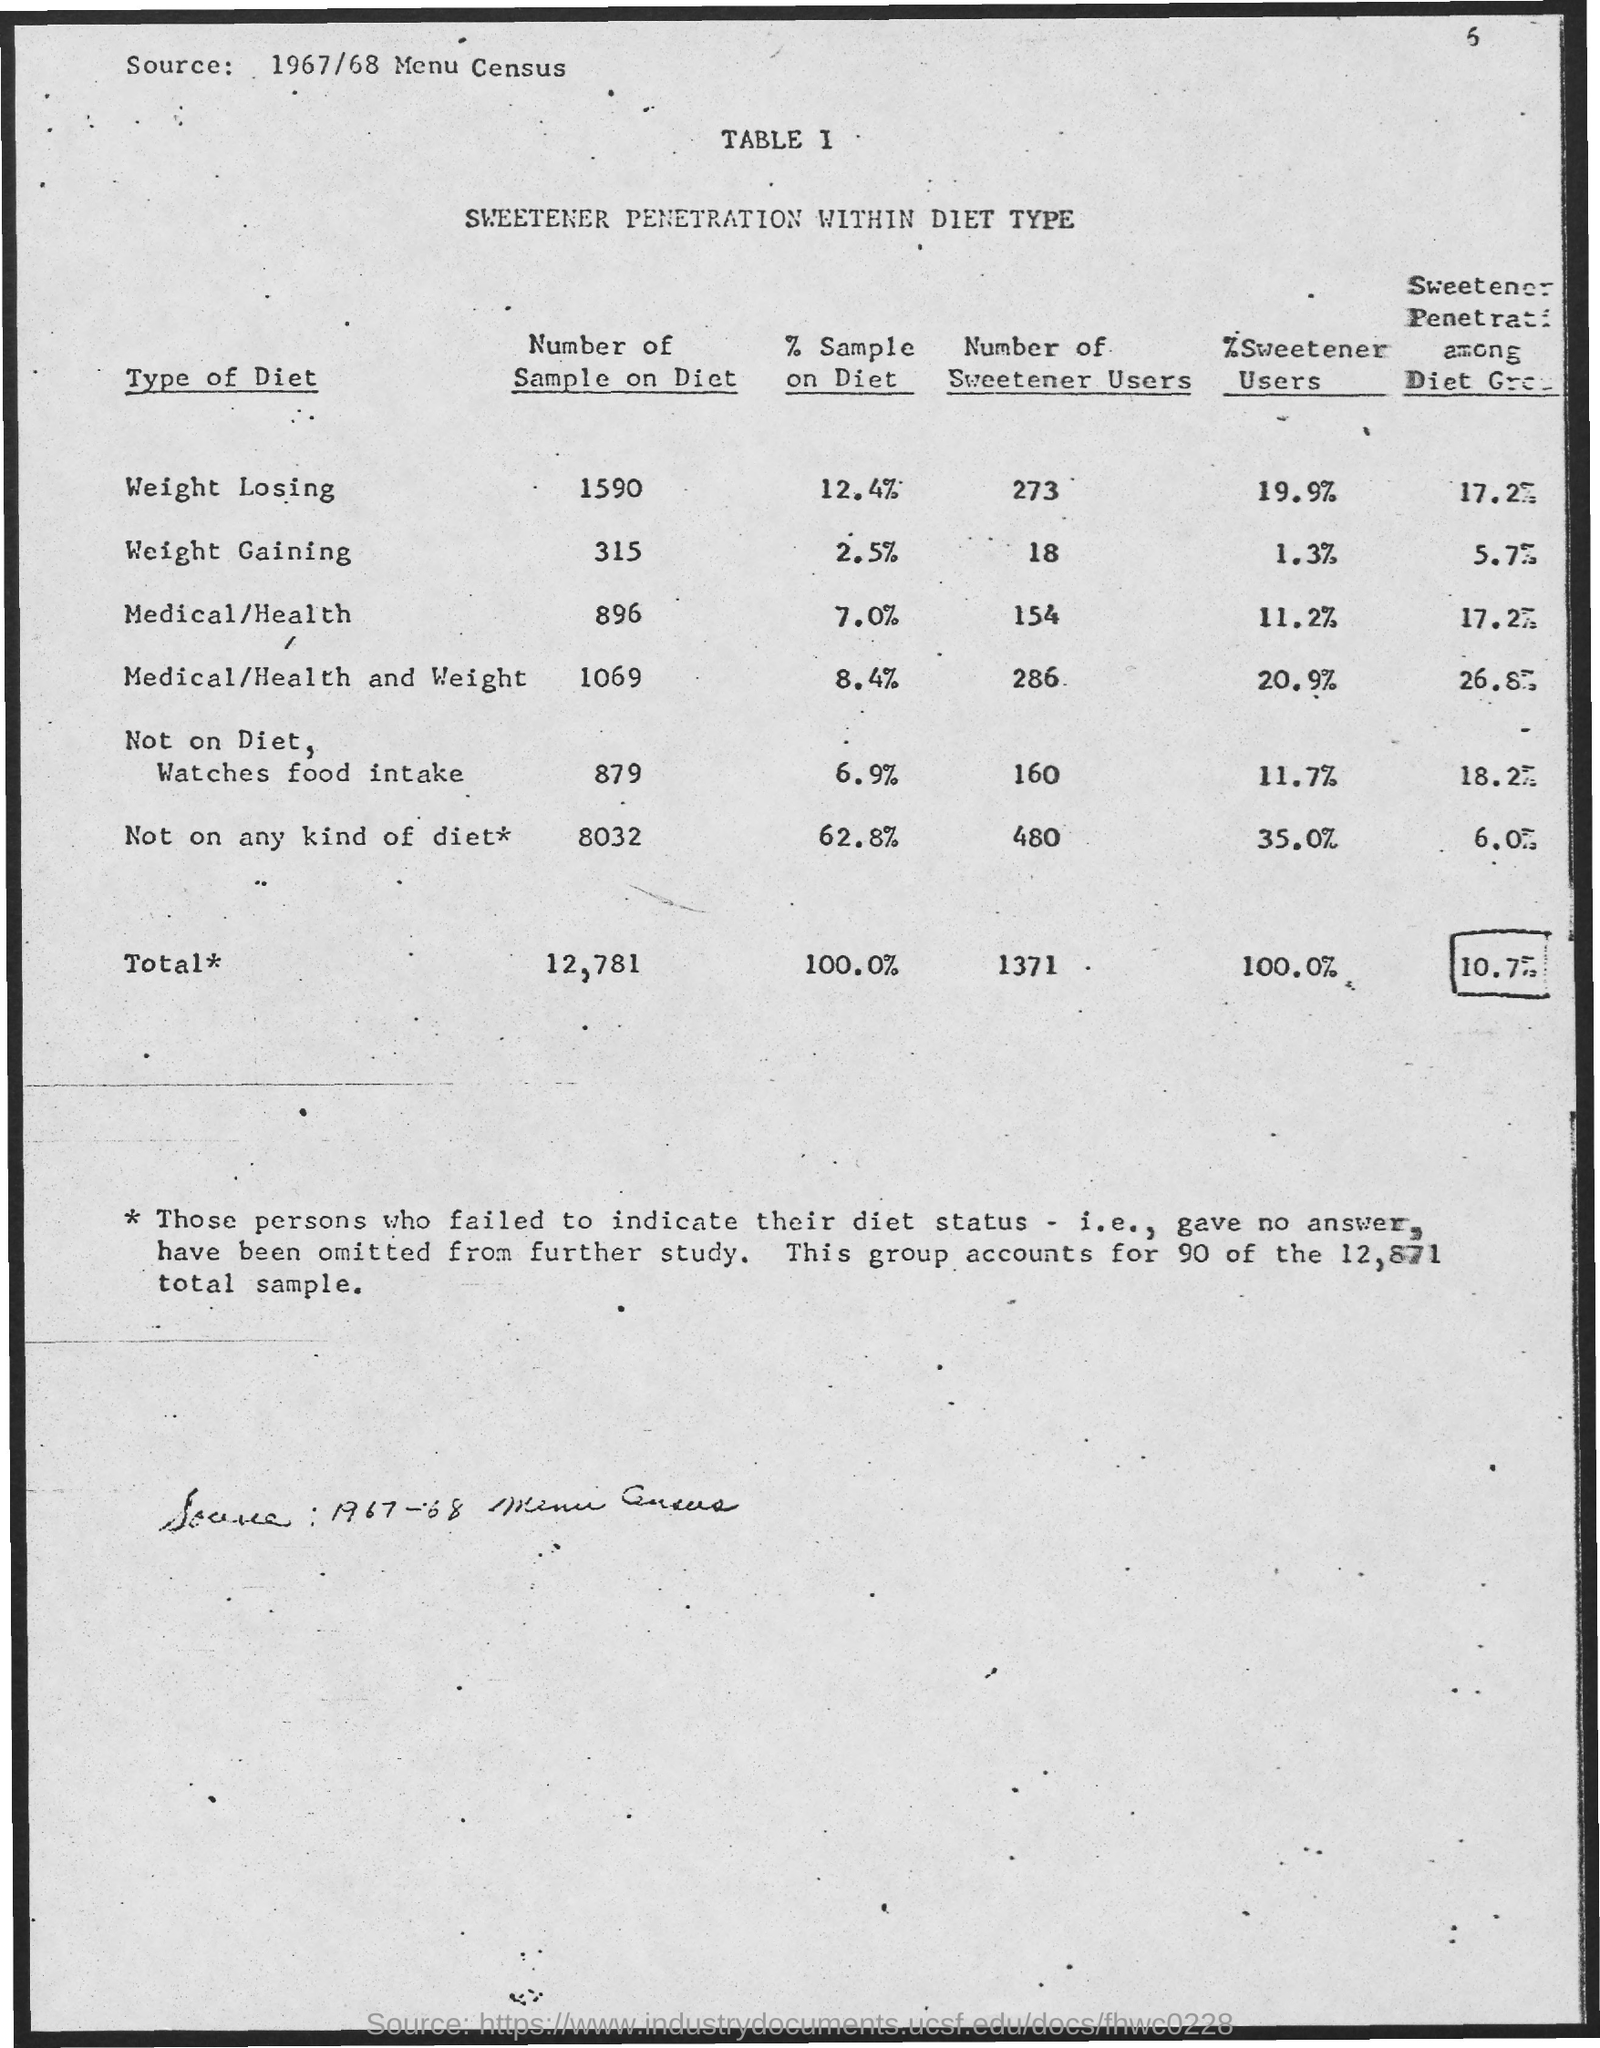Draw attention to some important aspects in this diagram. There are a total of 12,781 samples in the Diet subgroup. 